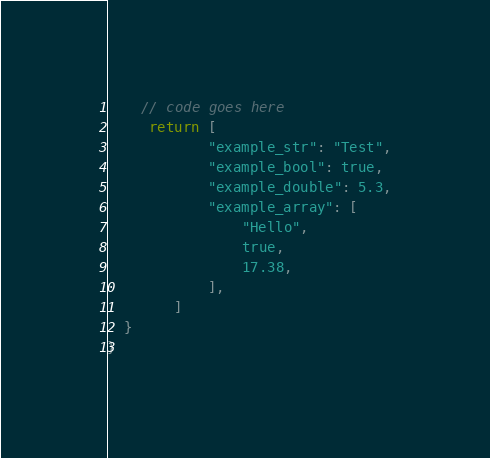Convert code to text. <code><loc_0><loc_0><loc_500><loc_500><_Swift_>    // code goes here
     return [
            "example_str": "Test",
            "example_bool": true,
            "example_double": 5.3,
            "example_array": [
                "Hello",
                true,
                17.38,
            ],
        ]
  }
}
</code> 